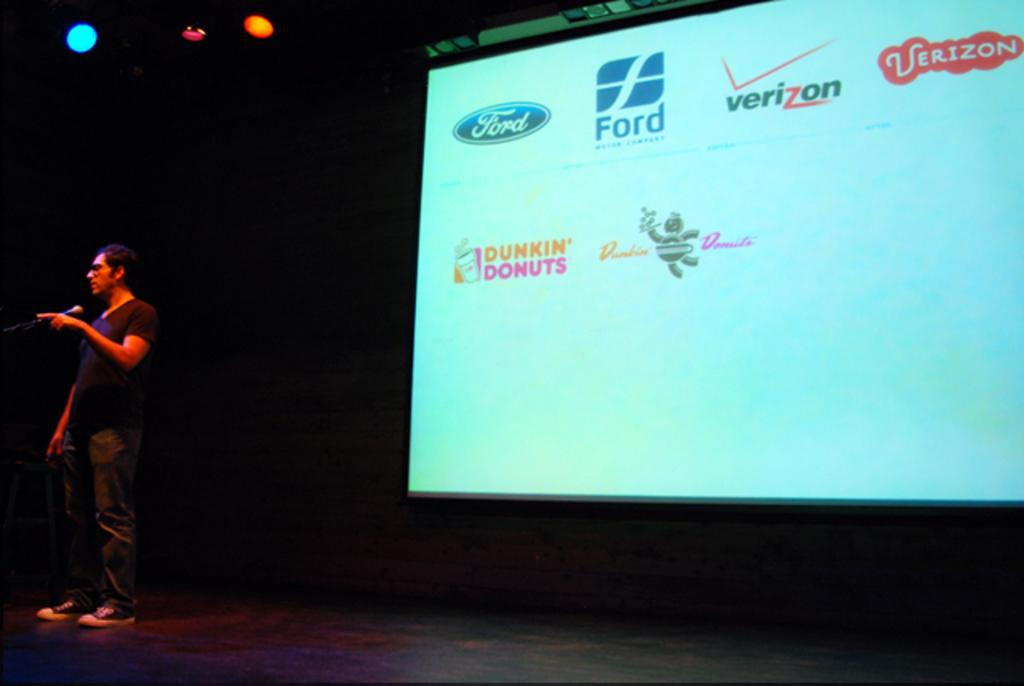What is the motor company that's displayed on the screen?
Provide a short and direct response. Ford. What is the coffee company being displayed?
Provide a short and direct response. Dunkin donuts. 